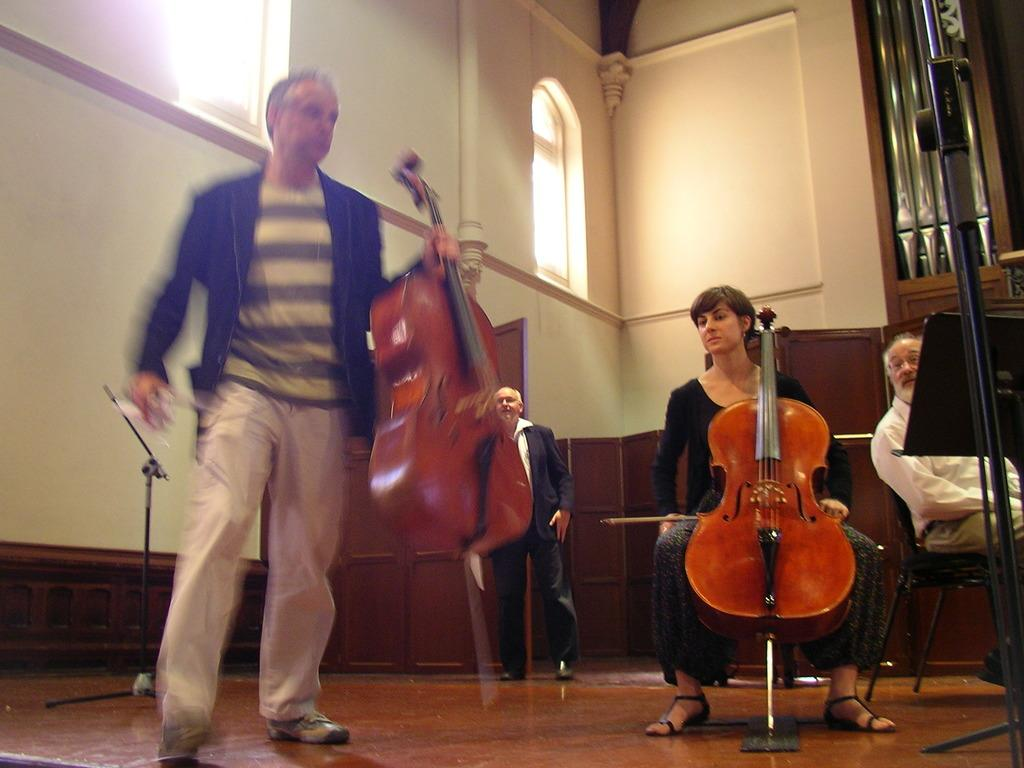What are the people in the image doing? The people in the image are standing and sitting while holding musical instruments. What can be seen in the background of the image? There is a wall in the background of the image. What type of harmony can be heard coming from the instruments in the image? There is no sound in the image, so it is not possible to determine the harmony of the instruments. 